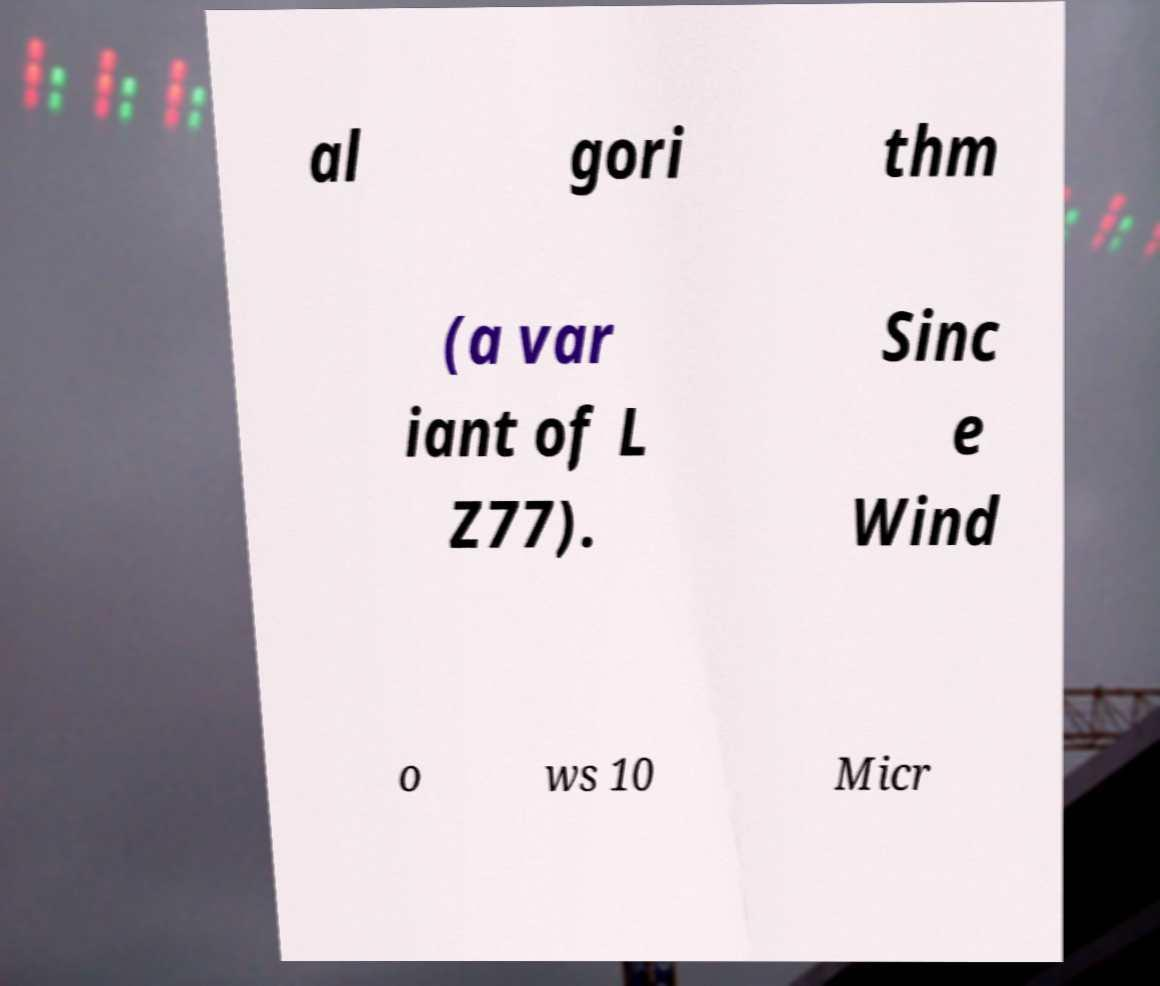Can you read and provide the text displayed in the image?This photo seems to have some interesting text. Can you extract and type it out for me? al gori thm (a var iant of L Z77). Sinc e Wind o ws 10 Micr 